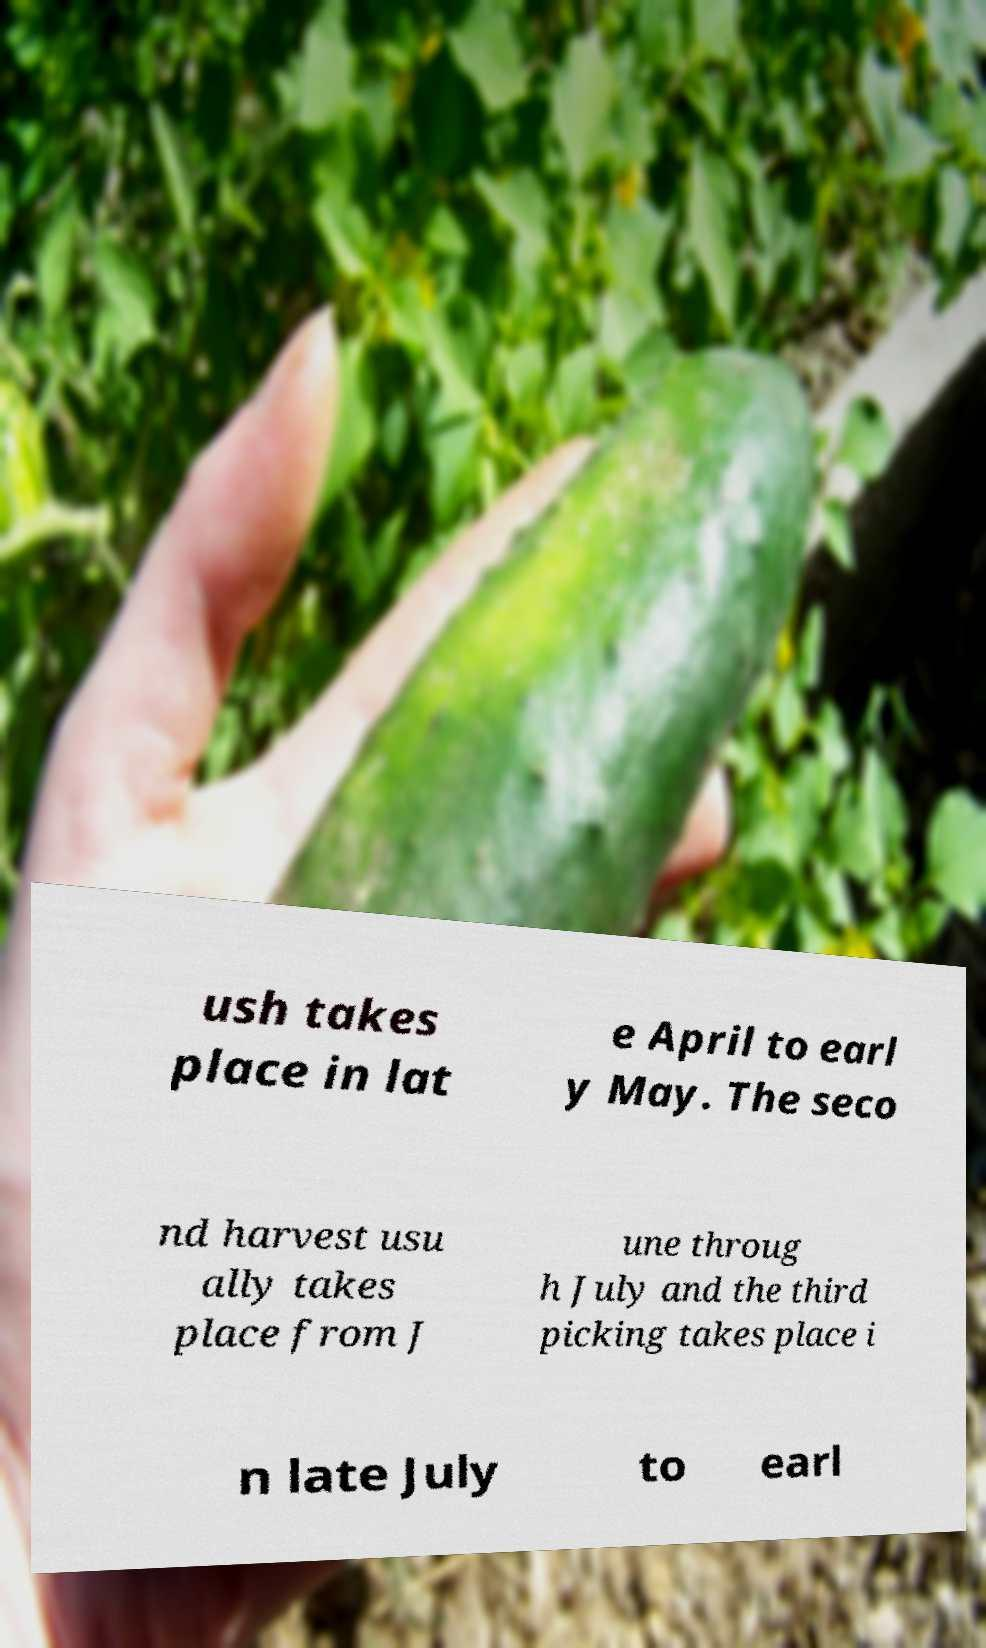I need the written content from this picture converted into text. Can you do that? ush takes place in lat e April to earl y May. The seco nd harvest usu ally takes place from J une throug h July and the third picking takes place i n late July to earl 